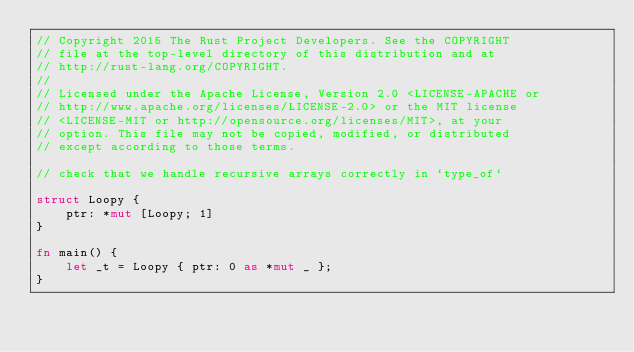<code> <loc_0><loc_0><loc_500><loc_500><_Rust_>// Copyright 2015 The Rust Project Developers. See the COPYRIGHT
// file at the top-level directory of this distribution and at
// http://rust-lang.org/COPYRIGHT.
//
// Licensed under the Apache License, Version 2.0 <LICENSE-APACHE or
// http://www.apache.org/licenses/LICENSE-2.0> or the MIT license
// <LICENSE-MIT or http://opensource.org/licenses/MIT>, at your
// option. This file may not be copied, modified, or distributed
// except according to those terms.

// check that we handle recursive arrays correctly in `type_of`

struct Loopy {
    ptr: *mut [Loopy; 1]
}

fn main() {
    let _t = Loopy { ptr: 0 as *mut _ };
}
</code> 